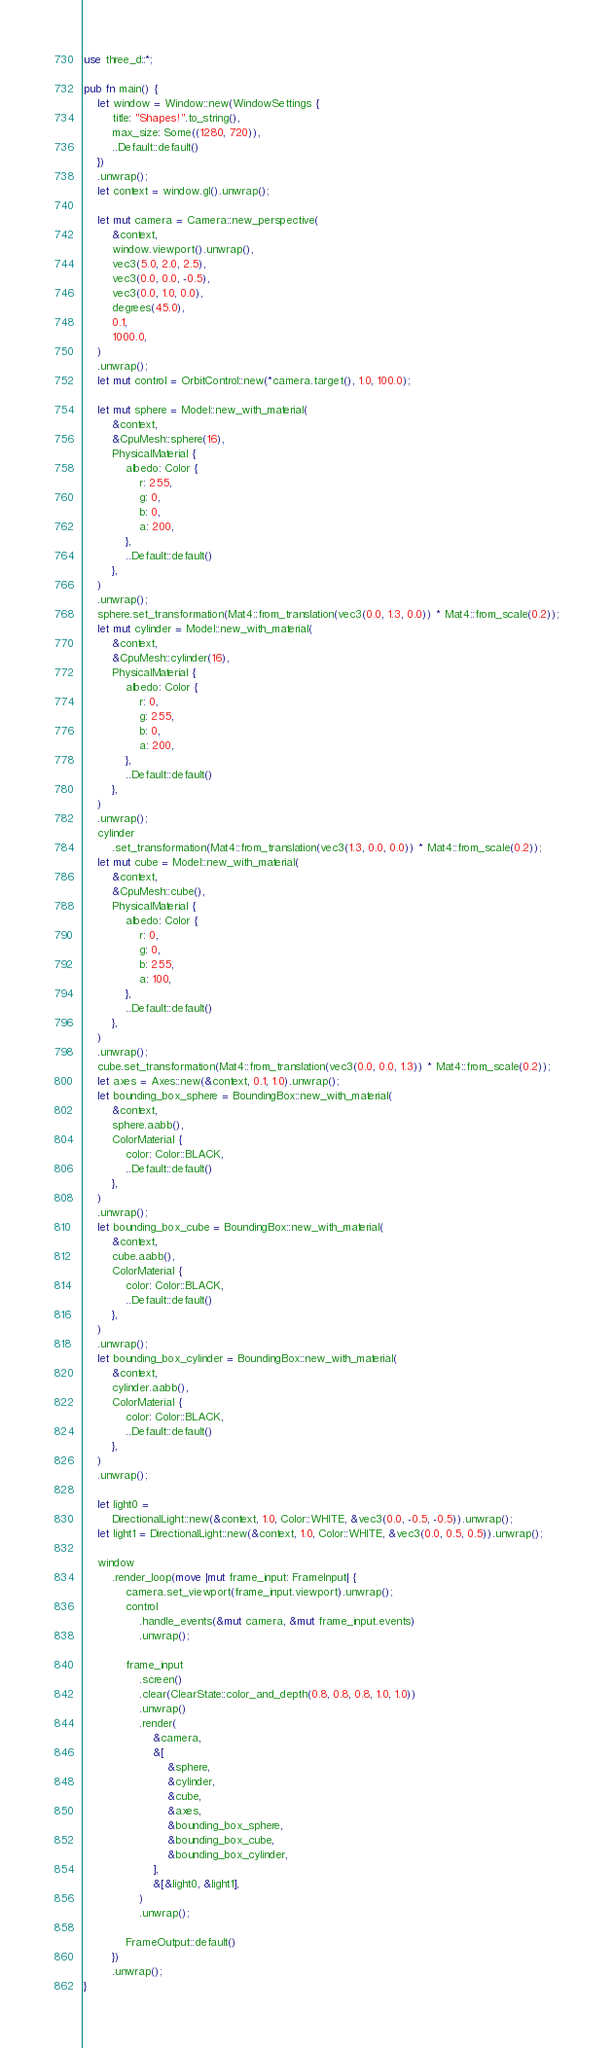Convert code to text. <code><loc_0><loc_0><loc_500><loc_500><_Rust_>use three_d::*;

pub fn main() {
    let window = Window::new(WindowSettings {
        title: "Shapes!".to_string(),
        max_size: Some((1280, 720)),
        ..Default::default()
    })
    .unwrap();
    let context = window.gl().unwrap();

    let mut camera = Camera::new_perspective(
        &context,
        window.viewport().unwrap(),
        vec3(5.0, 2.0, 2.5),
        vec3(0.0, 0.0, -0.5),
        vec3(0.0, 1.0, 0.0),
        degrees(45.0),
        0.1,
        1000.0,
    )
    .unwrap();
    let mut control = OrbitControl::new(*camera.target(), 1.0, 100.0);

    let mut sphere = Model::new_with_material(
        &context,
        &CpuMesh::sphere(16),
        PhysicalMaterial {
            albedo: Color {
                r: 255,
                g: 0,
                b: 0,
                a: 200,
            },
            ..Default::default()
        },
    )
    .unwrap();
    sphere.set_transformation(Mat4::from_translation(vec3(0.0, 1.3, 0.0)) * Mat4::from_scale(0.2));
    let mut cylinder = Model::new_with_material(
        &context,
        &CpuMesh::cylinder(16),
        PhysicalMaterial {
            albedo: Color {
                r: 0,
                g: 255,
                b: 0,
                a: 200,
            },
            ..Default::default()
        },
    )
    .unwrap();
    cylinder
        .set_transformation(Mat4::from_translation(vec3(1.3, 0.0, 0.0)) * Mat4::from_scale(0.2));
    let mut cube = Model::new_with_material(
        &context,
        &CpuMesh::cube(),
        PhysicalMaterial {
            albedo: Color {
                r: 0,
                g: 0,
                b: 255,
                a: 100,
            },
            ..Default::default()
        },
    )
    .unwrap();
    cube.set_transformation(Mat4::from_translation(vec3(0.0, 0.0, 1.3)) * Mat4::from_scale(0.2));
    let axes = Axes::new(&context, 0.1, 1.0).unwrap();
    let bounding_box_sphere = BoundingBox::new_with_material(
        &context,
        sphere.aabb(),
        ColorMaterial {
            color: Color::BLACK,
            ..Default::default()
        },
    )
    .unwrap();
    let bounding_box_cube = BoundingBox::new_with_material(
        &context,
        cube.aabb(),
        ColorMaterial {
            color: Color::BLACK,
            ..Default::default()
        },
    )
    .unwrap();
    let bounding_box_cylinder = BoundingBox::new_with_material(
        &context,
        cylinder.aabb(),
        ColorMaterial {
            color: Color::BLACK,
            ..Default::default()
        },
    )
    .unwrap();

    let light0 =
        DirectionalLight::new(&context, 1.0, Color::WHITE, &vec3(0.0, -0.5, -0.5)).unwrap();
    let light1 = DirectionalLight::new(&context, 1.0, Color::WHITE, &vec3(0.0, 0.5, 0.5)).unwrap();

    window
        .render_loop(move |mut frame_input: FrameInput| {
            camera.set_viewport(frame_input.viewport).unwrap();
            control
                .handle_events(&mut camera, &mut frame_input.events)
                .unwrap();

            frame_input
                .screen()
                .clear(ClearState::color_and_depth(0.8, 0.8, 0.8, 1.0, 1.0))
                .unwrap()
                .render(
                    &camera,
                    &[
                        &sphere,
                        &cylinder,
                        &cube,
                        &axes,
                        &bounding_box_sphere,
                        &bounding_box_cube,
                        &bounding_box_cylinder,
                    ],
                    &[&light0, &light1],
                )
                .unwrap();

            FrameOutput::default()
        })
        .unwrap();
}
</code> 